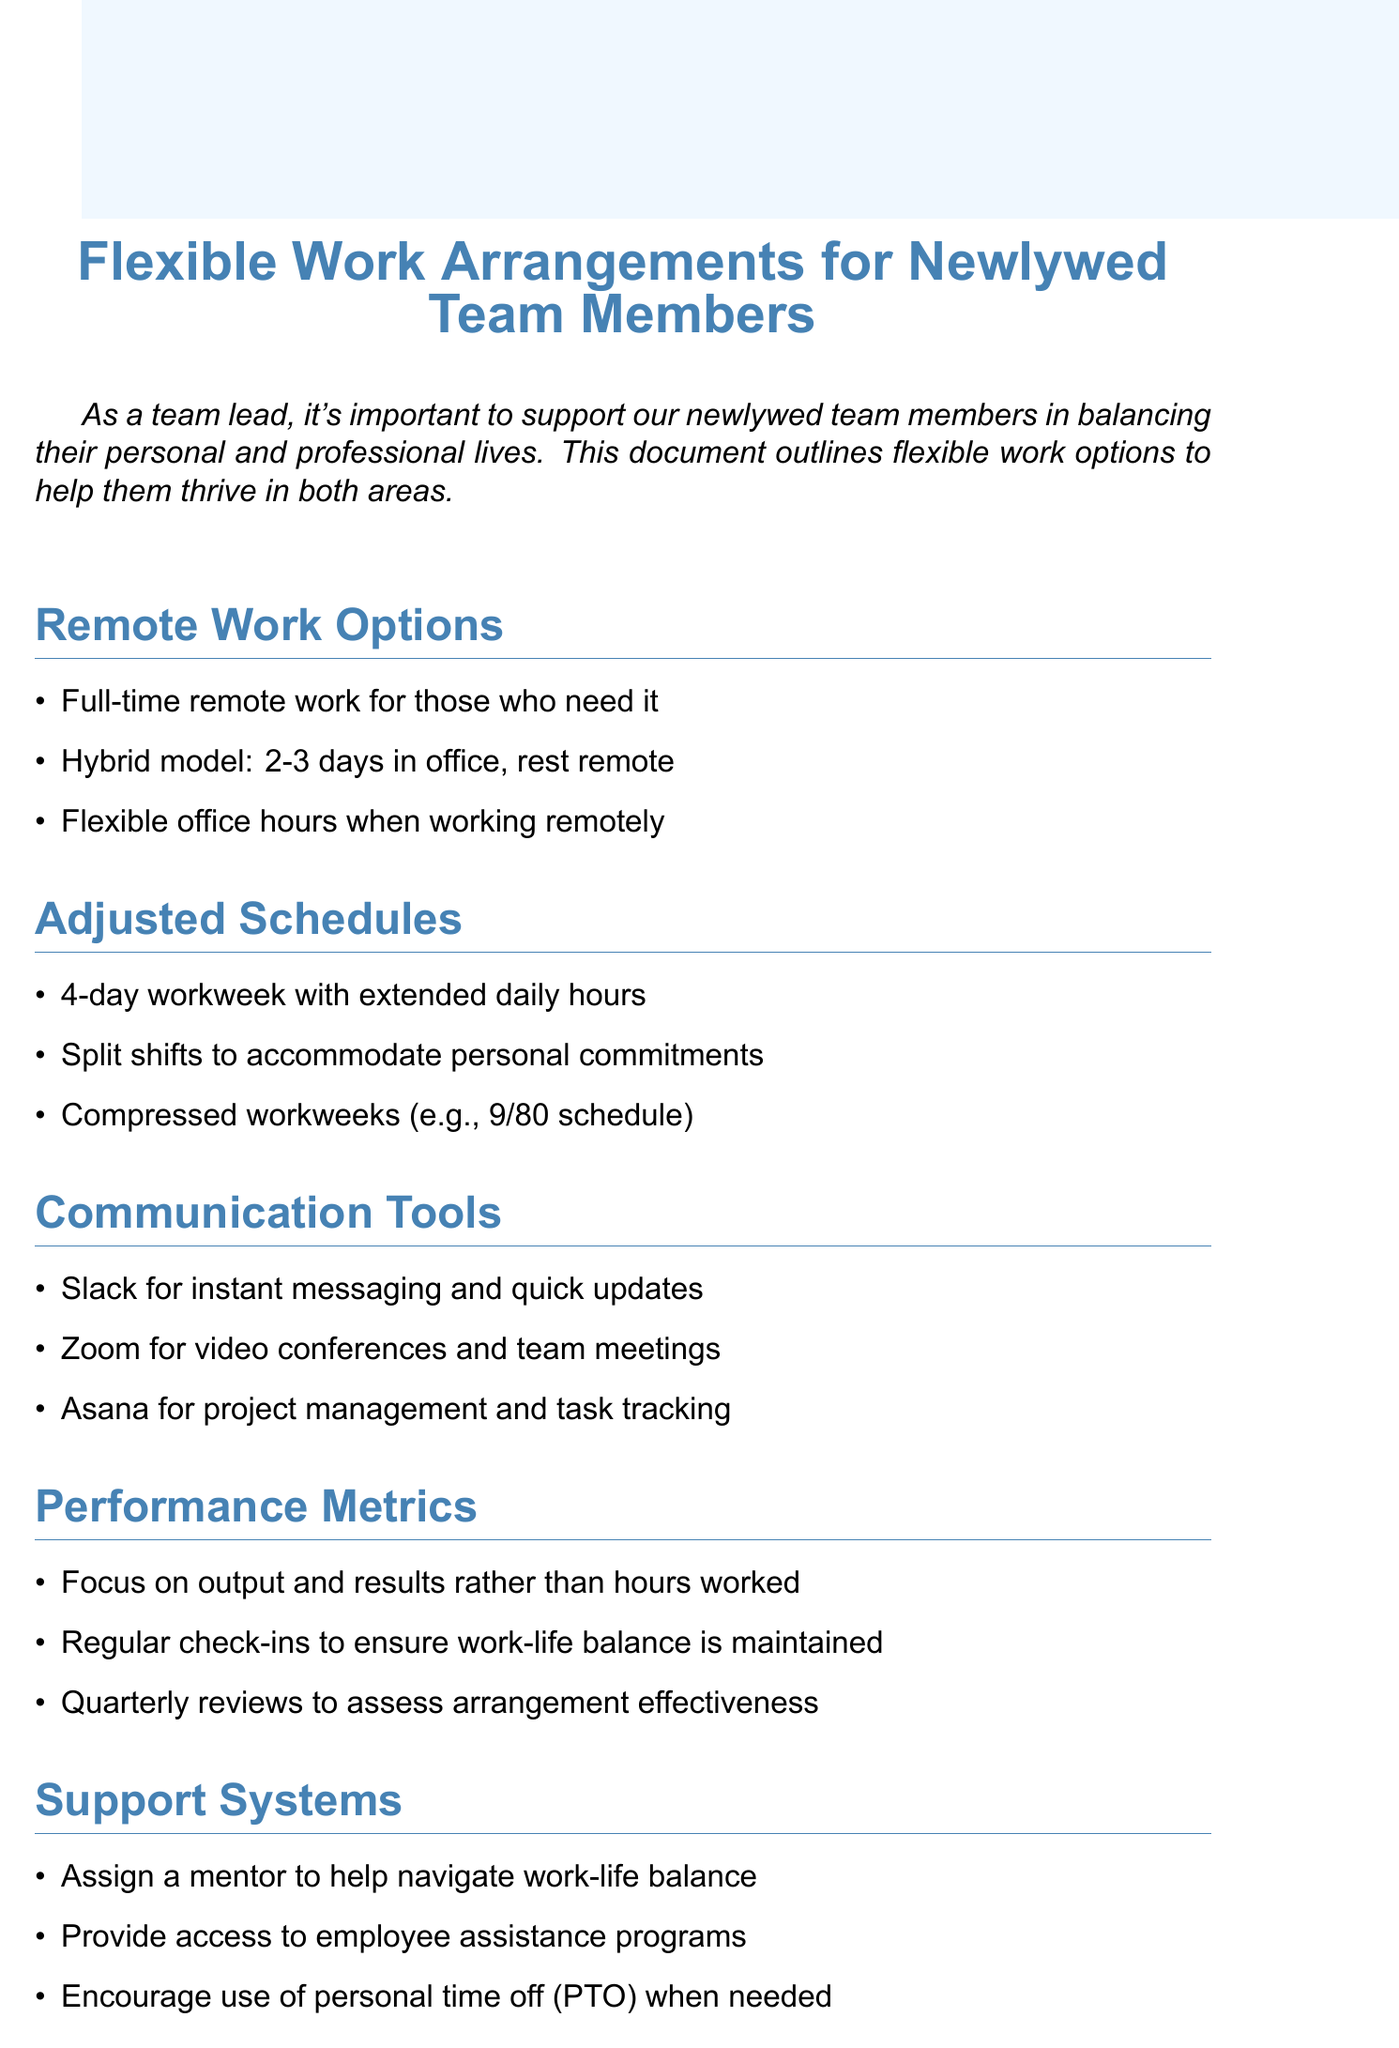what is the title of the document? The title given at the beginning of the document specifies the main subject being discussed, which is related to support for newlywed team members.
Answer: Flexible Work Arrangements for Newlywed Team Members how many remote work options are listed? The document enumerates different remote work options to assist newlywed team members in their professional settings.
Answer: 3 what is one adjusted schedule option mentioned? The document outlines various adjusted scheduling strategies that can be adopted for better work-life balance for newlywed employees.
Answer: 4-day workweek with extended daily hours which tool is suggested for instant messaging? The document specifies a tool that allows for quick communication and updates among team members, aiding in remote collaboration.
Answer: Slack how often should flexible work arrangements be reviewed? The document indicates a timeframe for the evaluation of the effectiveness of the flexible work setups in place.
Answer: every 6 months what is a focus of the performance metrics? The document emphasizes a particular aspect of performance evaluation that should be prioritized in measuring employee productivity.
Answer: output and results rather than hours worked who should be assigned to help navigate work-life balance? The document suggests a supportive measure for newlywed team members to help them manage their professional and personal commitments effectively.
Answer: a mentor what type of assistance is offered to employees? The document mentions a specific resource aimed at providing support for personal and professional challenges faced by newlywed team members.
Answer: employee assistance programs 